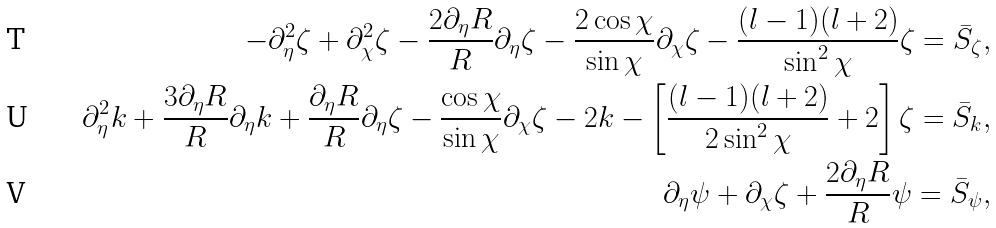<formula> <loc_0><loc_0><loc_500><loc_500>- \partial _ { \eta } ^ { 2 } \zeta + \partial _ { \chi } ^ { 2 } \zeta - \frac { 2 \partial _ { \eta } R } { R } \partial _ { \eta } \zeta - \frac { 2 \cos \chi } { \sin \chi } \partial _ { \chi } \zeta - \frac { ( l - 1 ) ( l + 2 ) } { \sin ^ { 2 } \chi } \zeta = \bar { S } _ { \zeta } , \\ \partial _ { \eta } ^ { 2 } k + \frac { 3 \partial _ { \eta } R } { R } \partial _ { \eta } k + \frac { \partial _ { \eta } R } { R } \partial _ { \eta } \zeta - \frac { \cos \chi } { \sin \chi } \partial _ { \chi } \zeta - 2 k - \left [ \frac { ( l - 1 ) ( l + 2 ) } { 2 \sin ^ { 2 } \chi } + 2 \right ] \zeta = \bar { S } _ { k } , \\ \partial _ { \eta } \psi + \partial _ { \chi } \zeta + \frac { 2 \partial _ { \eta } R } { R } \psi = \bar { S } _ { \psi } ,</formula> 